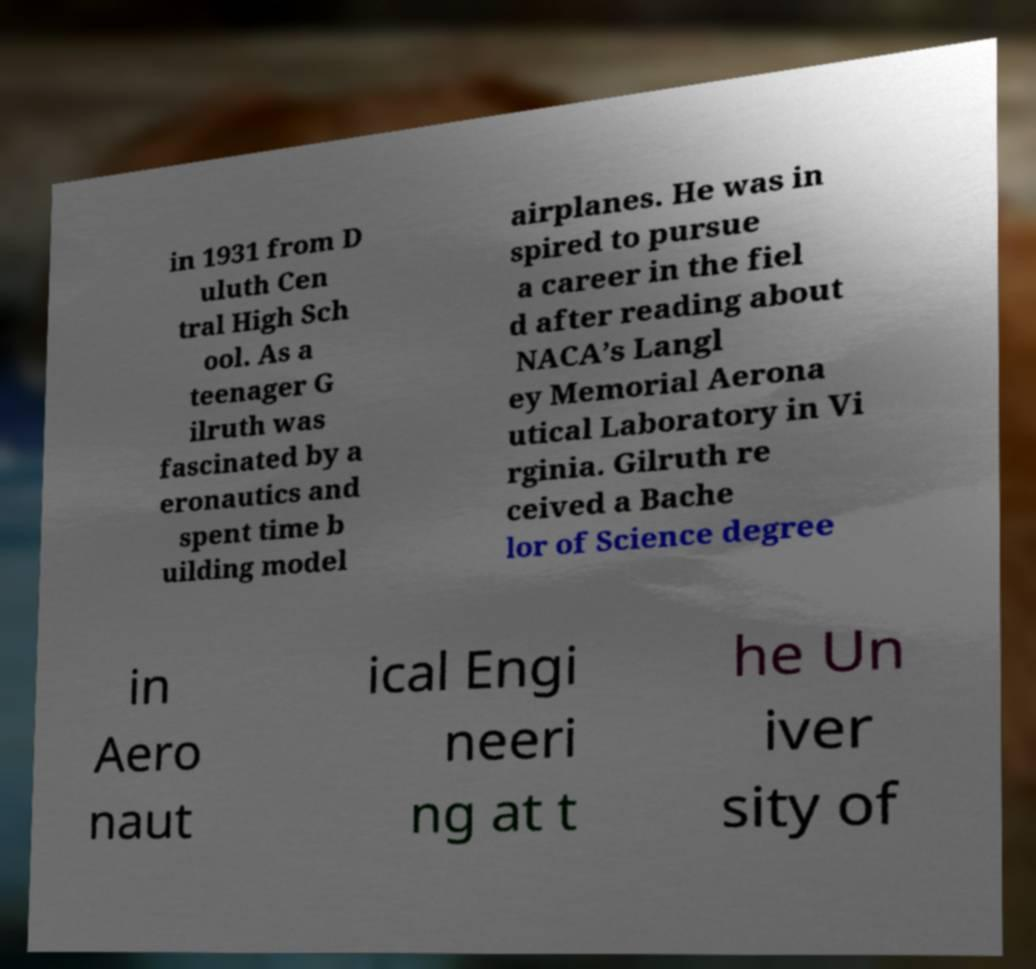There's text embedded in this image that I need extracted. Can you transcribe it verbatim? in 1931 from D uluth Cen tral High Sch ool. As a teenager G ilruth was fascinated by a eronautics and spent time b uilding model airplanes. He was in spired to pursue a career in the fiel d after reading about NACA’s Langl ey Memorial Aerona utical Laboratory in Vi rginia. Gilruth re ceived a Bache lor of Science degree in Aero naut ical Engi neeri ng at t he Un iver sity of 